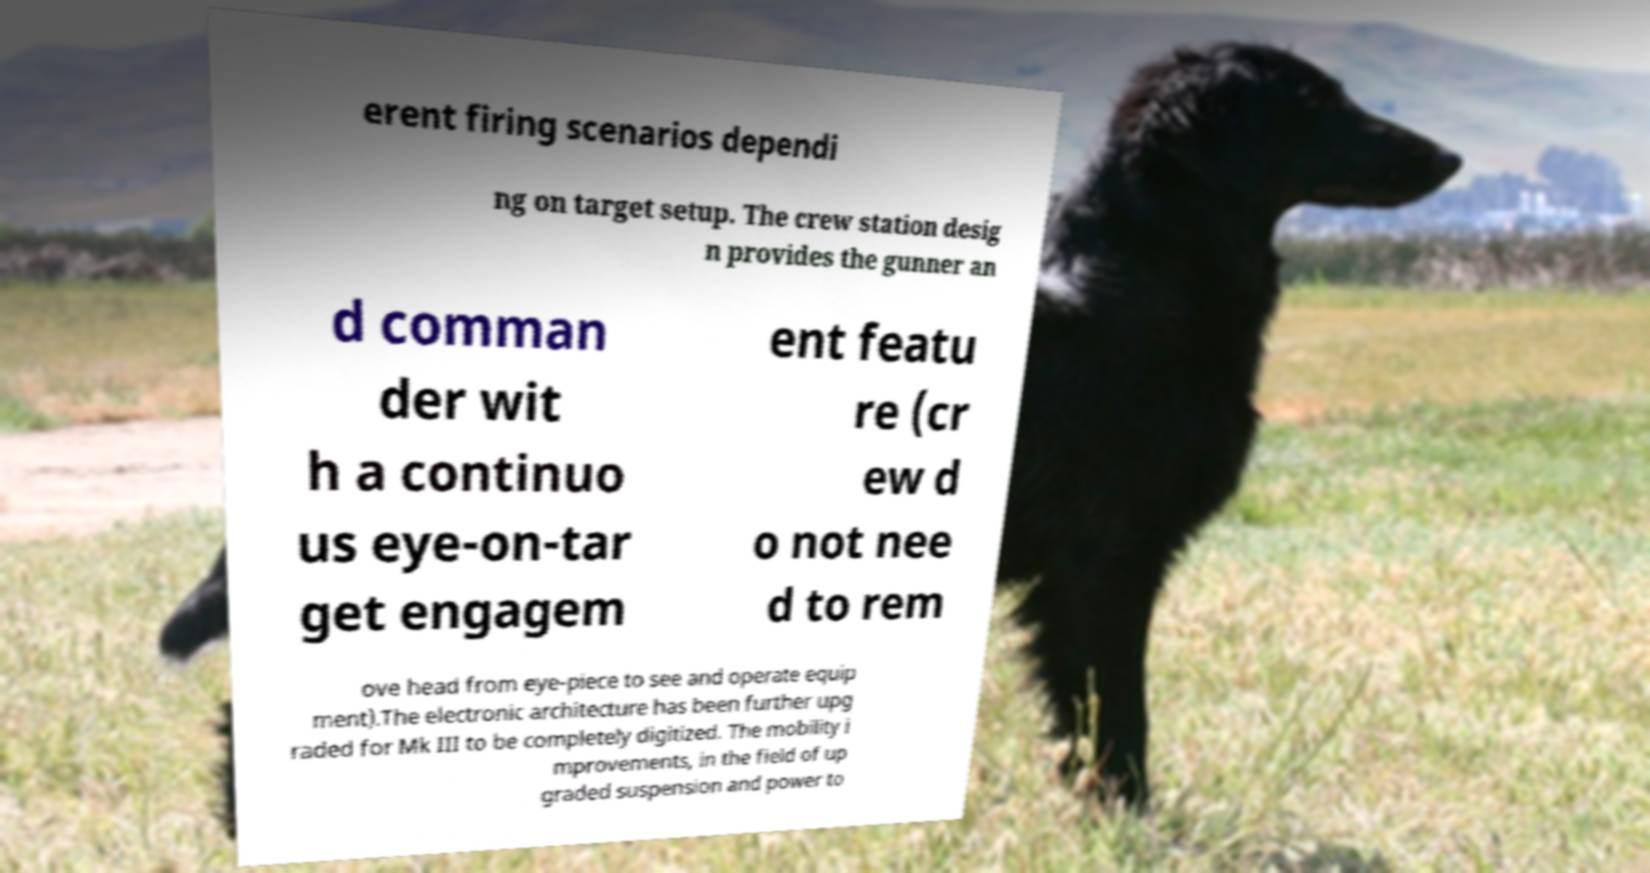Please identify and transcribe the text found in this image. erent firing scenarios dependi ng on target setup. The crew station desig n provides the gunner an d comman der wit h a continuo us eye-on-tar get engagem ent featu re (cr ew d o not nee d to rem ove head from eye-piece to see and operate equip ment).The electronic architecture has been further upg raded for Mk III to be completely digitized. The mobility i mprovements, in the field of up graded suspension and power to 